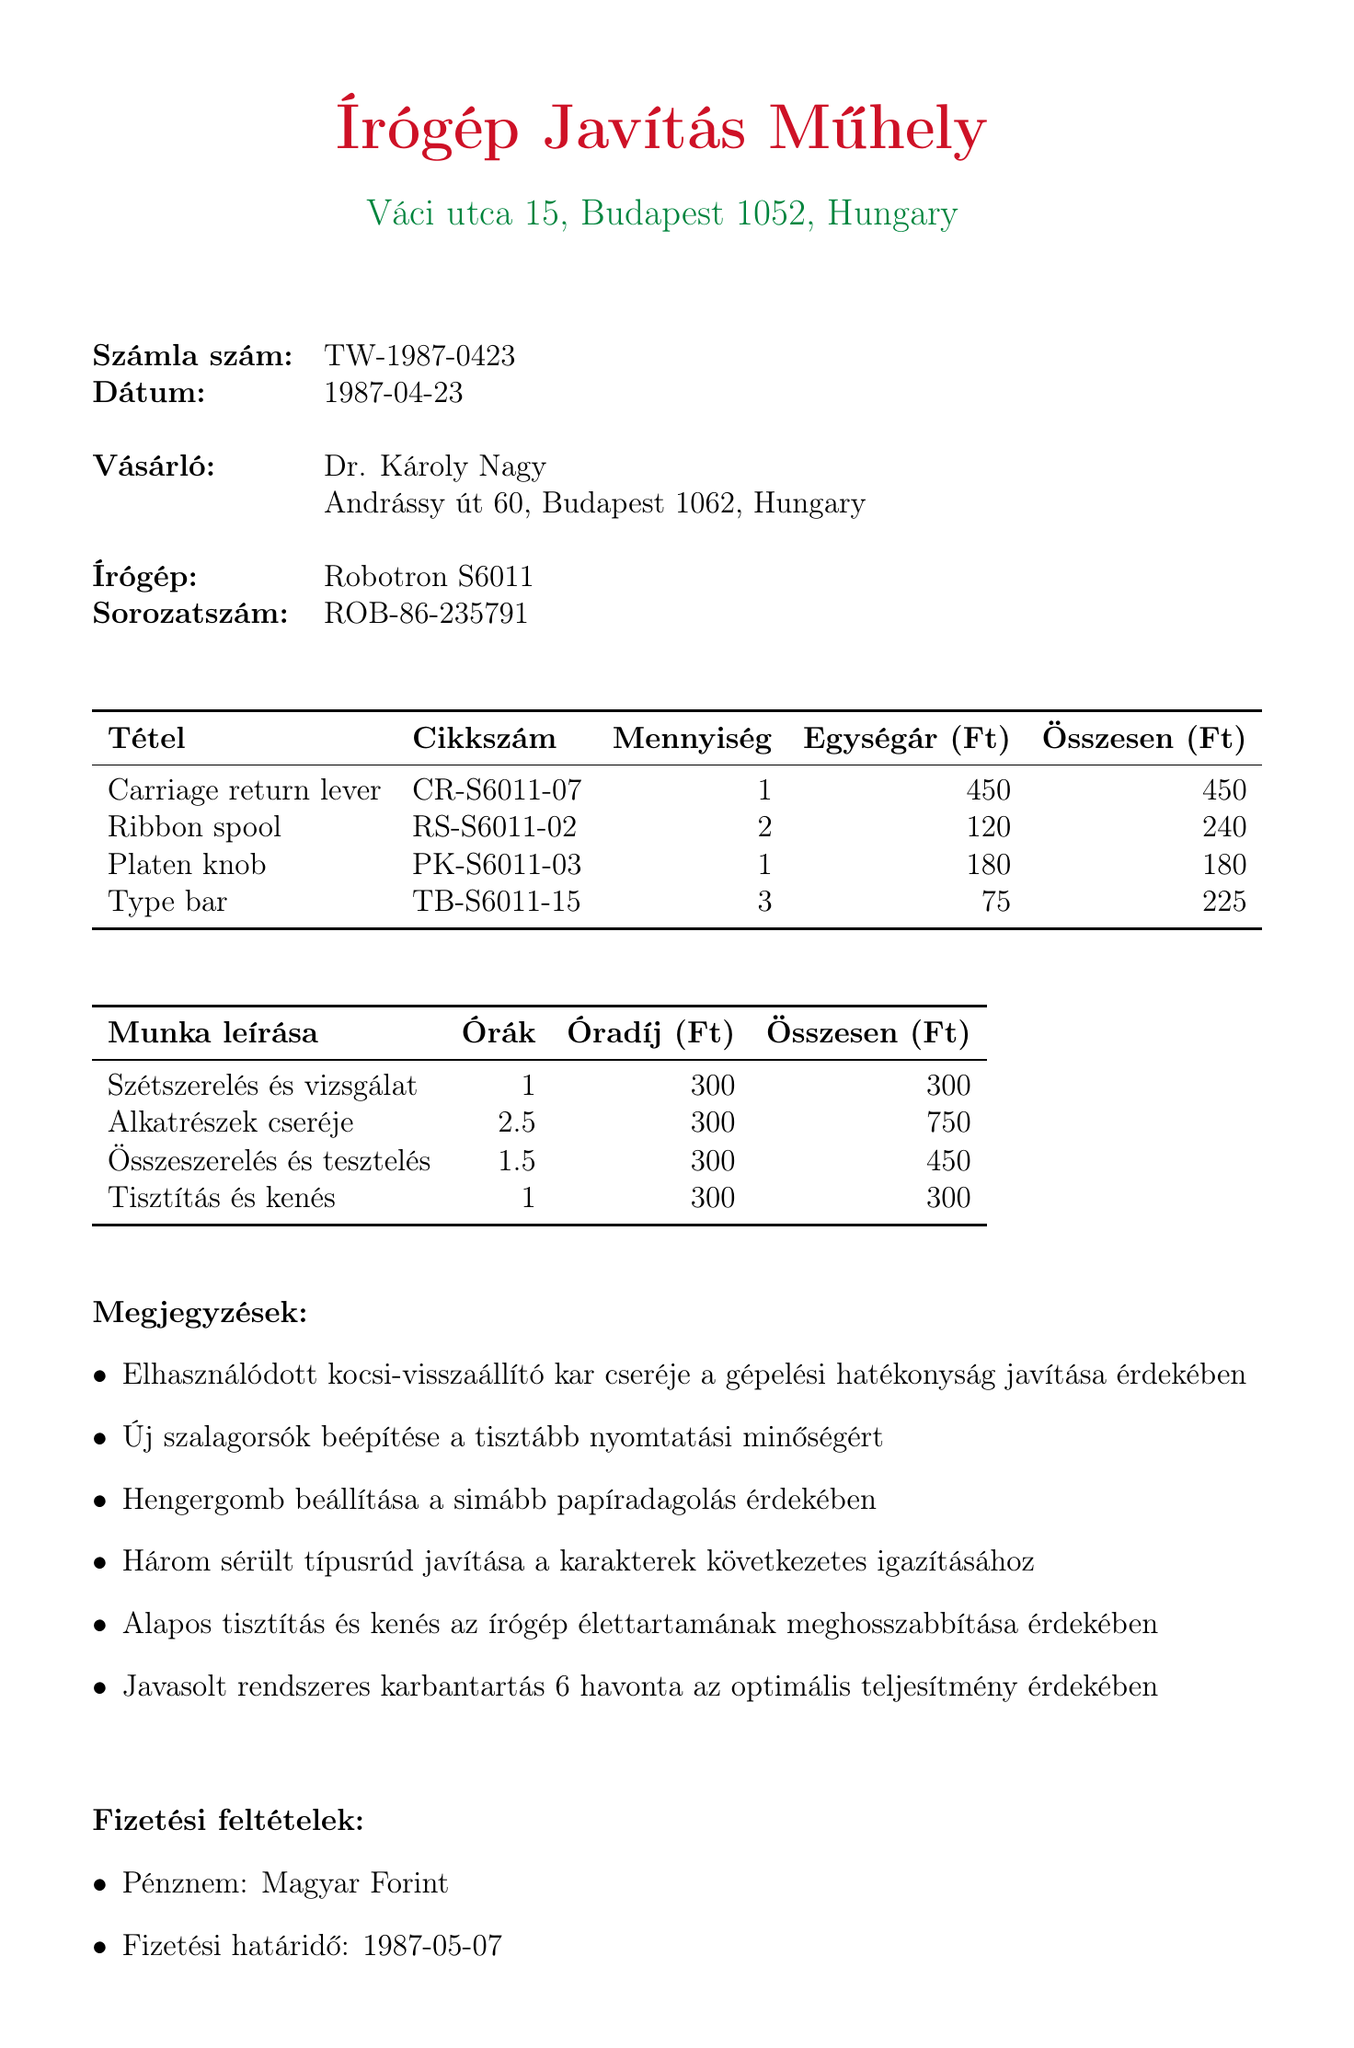What is the invoice number? The invoice number is stated at the top of the document for identification purposes.
Answer: TW-1987-0423 What is the total amount for the replacement parts? The total for replacement parts is calculated by adding the total values listed for each part.
Answer: 1085 Ft Who is the customer? The customer is the individual or entity who received the service and is responsible for payment.
Answer: Dr. Károly Nagy What is the payment due date? The due date is specified in the payment terms section of the invoice.
Answer: 1987-05-07 How many hours were billed for 'Parts replacement'? The hours billed for each labor description are detailed in the labor section.
Answer: 2.5 Which part has the highest unit price? By comparing the unit prices listed for each part, we can identify the most expensive item.
Answer: Carriage return lever What is the description of the first labor charge? The description for each labor charge provides insight into the work performed on the typewriter.
Answer: Disassembly and inspection What currency is used for payment? The currency of the invoice is mentioned in the payment terms.
Answer: Hungarian Forint 